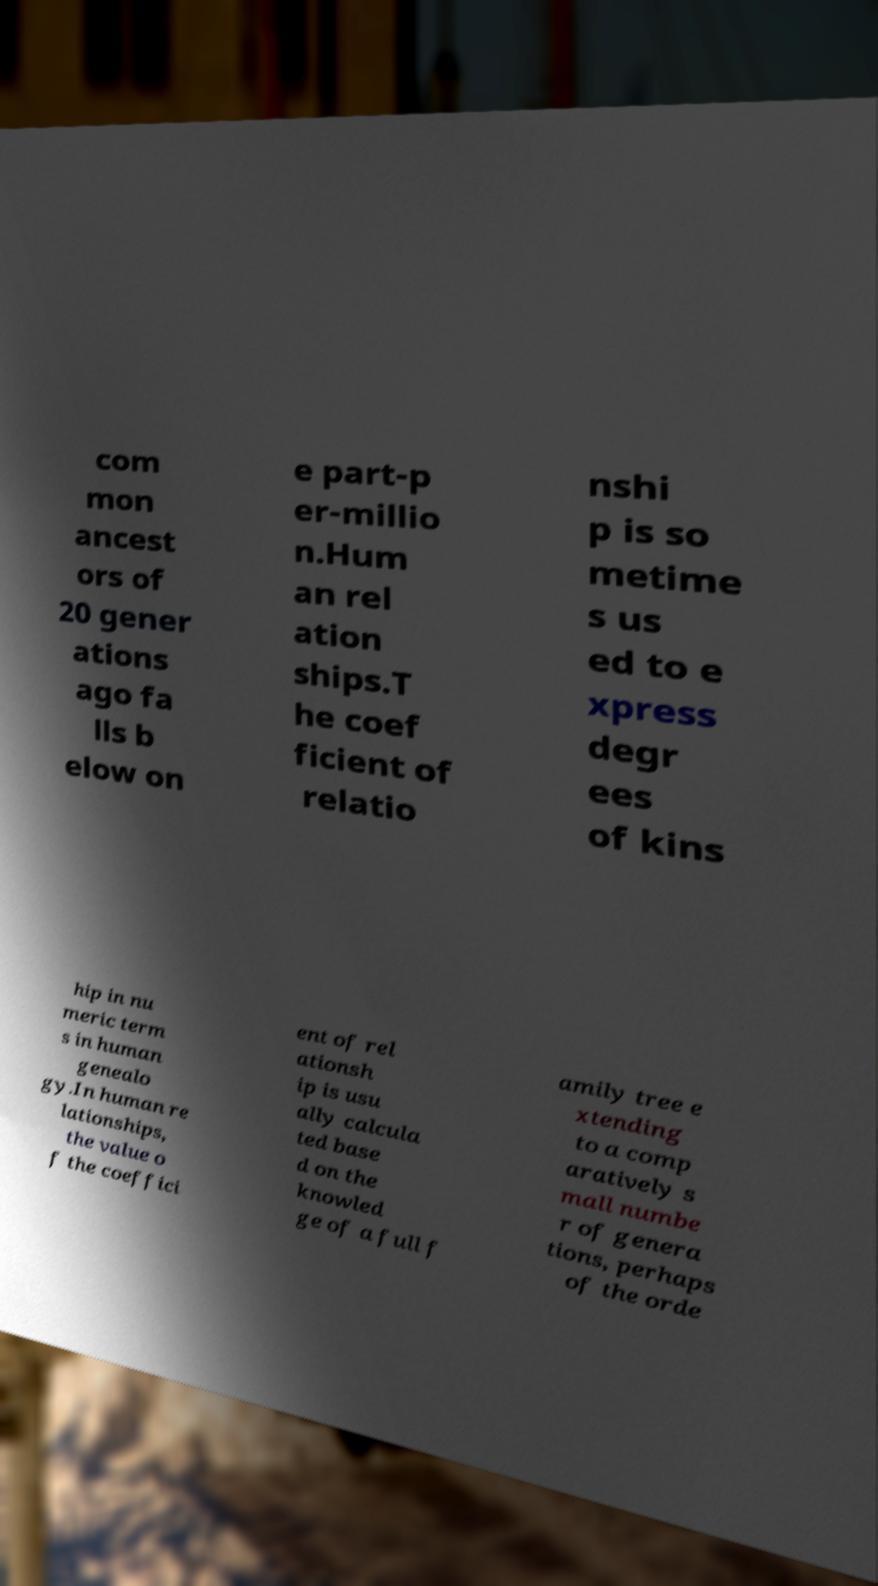Can you read and provide the text displayed in the image?This photo seems to have some interesting text. Can you extract and type it out for me? com mon ancest ors of 20 gener ations ago fa lls b elow on e part-p er-millio n.Hum an rel ation ships.T he coef ficient of relatio nshi p is so metime s us ed to e xpress degr ees of kins hip in nu meric term s in human genealo gy.In human re lationships, the value o f the coeffici ent of rel ationsh ip is usu ally calcula ted base d on the knowled ge of a full f amily tree e xtending to a comp aratively s mall numbe r of genera tions, perhaps of the orde 